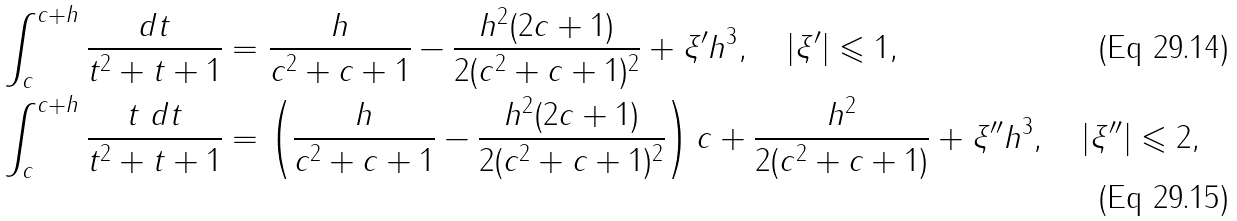<formula> <loc_0><loc_0><loc_500><loc_500>\int _ { c } ^ { c + h } \frac { d t } { t ^ { 2 } + t + 1 } & = \frac { h } { c ^ { 2 } + c + 1 } - \frac { h ^ { 2 } ( 2 c + 1 ) } { 2 ( c ^ { 2 } + c + 1 ) ^ { 2 } } + \xi ^ { \prime } h ^ { 3 } , \quad | \xi ^ { \prime } | \leqslant 1 , \\ \int _ { c } ^ { c + h } \frac { t \ d t } { t ^ { 2 } + t + 1 } & = \left ( \frac { h } { c ^ { 2 } + c + 1 } - \frac { h ^ { 2 } ( 2 c + 1 ) } { 2 ( c ^ { 2 } + c + 1 ) ^ { 2 } } \right ) c + \frac { h ^ { 2 } } { 2 ( c ^ { 2 } + c + 1 ) } + \xi ^ { \prime \prime } h ^ { 3 } , \quad | \xi ^ { \prime \prime } | \leqslant 2 ,</formula> 